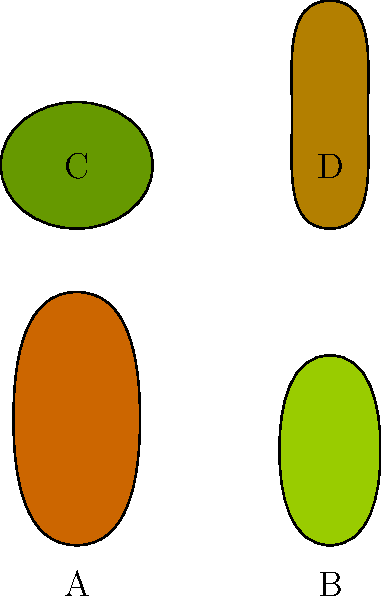As an expert in Ohio's native tree species, which of the leaf shapes (A, B, C, or D) most closely resembles the leaf of the Ohio Buckeye tree (Aesculus glabra), a species native to Ohio and the state tree? To identify the Ohio Buckeye leaf among the given options, let's consider the characteristics of the Ohio Buckeye leaf and compare them to the shapes provided:

1. Ohio Buckeye leaf characteristics:
   - Palmately compound leaf with 5-7 leaflets
   - Leaflets are elongated and oval-shaped
   - Leaflets are arranged in a fan-like pattern

2. Analyzing the given leaf shapes:
   A: This leaf is elongated and oval-shaped, similar to a single leaflet of the Ohio Buckeye.
   B: This leaf is shorter and wider, not matching the Ohio Buckeye leaflet shape.
   C: This leaf is wide and short, unlike the Ohio Buckeye leaflet.
   D: This leaf is narrow and elongated, closest in shape to an Ohio Buckeye leaflet.

3. Conclusion:
   While none of the shapes perfectly represent the entire compound leaf of the Ohio Buckeye, shape D most closely resembles a single leaflet of the Ohio Buckeye tree. It has the characteristic elongated, oval shape that is typical of Ohio Buckeye leaflets.
Answer: D 